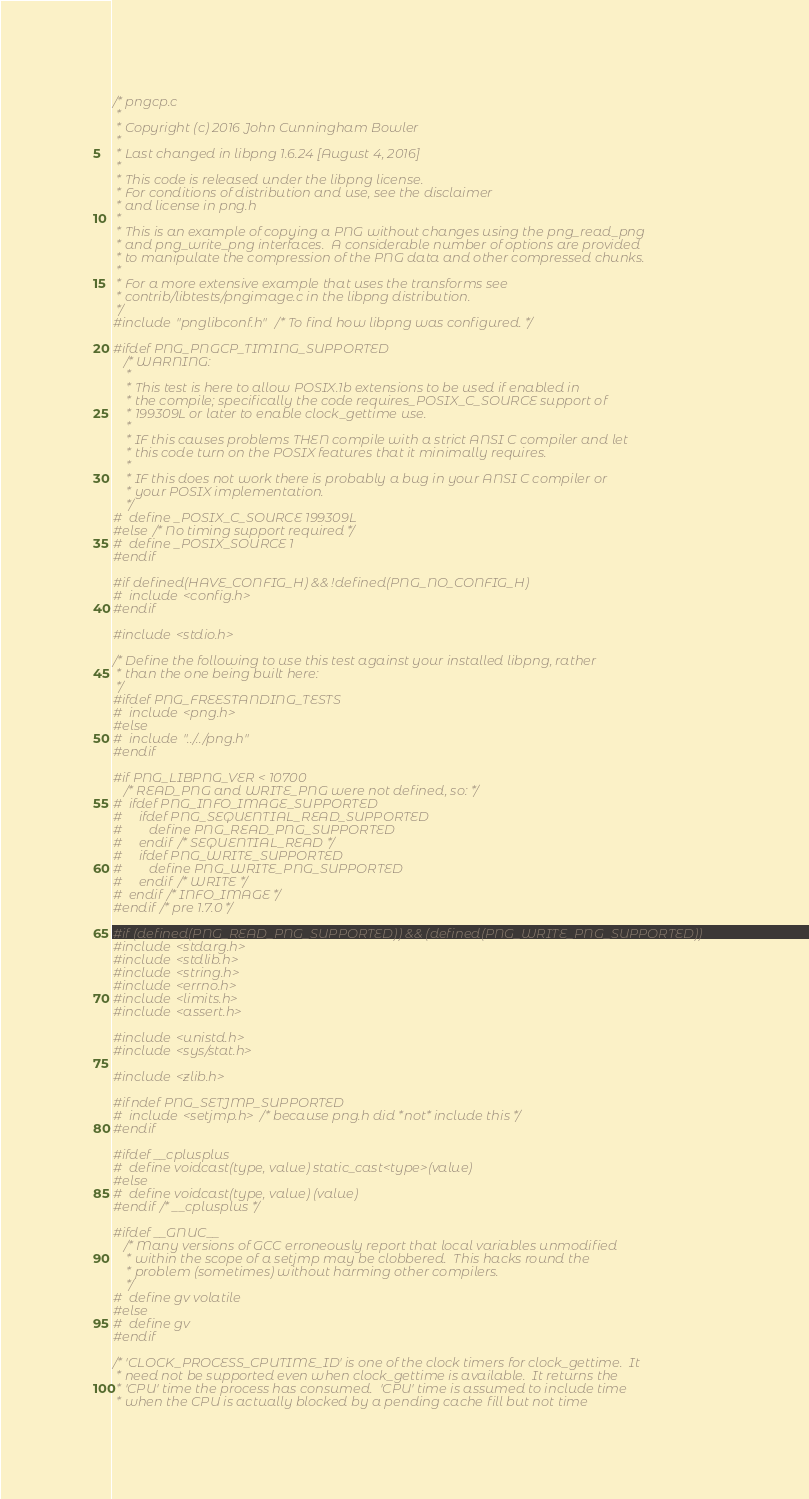<code> <loc_0><loc_0><loc_500><loc_500><_C_>/* pngcp.c
 *
 * Copyright (c) 2016 John Cunningham Bowler
 *
 * Last changed in libpng 1.6.24 [August 4, 2016]
 *
 * This code is released under the libpng license.
 * For conditions of distribution and use, see the disclaimer
 * and license in png.h
 *
 * This is an example of copying a PNG without changes using the png_read_png
 * and png_write_png interfaces.  A considerable number of options are provided
 * to manipulate the compression of the PNG data and other compressed chunks.
 *
 * For a more extensive example that uses the transforms see
 * contrib/libtests/pngimage.c in the libpng distribution.
 */
#include "pnglibconf.h" /* To find how libpng was configured. */

#ifdef PNG_PNGCP_TIMING_SUPPORTED
   /* WARNING:
    *
    * This test is here to allow POSIX.1b extensions to be used if enabled in
    * the compile; specifically the code requires_POSIX_C_SOURCE support of
    * 199309L or later to enable clock_gettime use.
    *
    * IF this causes problems THEN compile with a strict ANSI C compiler and let
    * this code turn on the POSIX features that it minimally requires.
    *
    * IF this does not work there is probably a bug in your ANSI C compiler or
    * your POSIX implementation.
    */
#  define _POSIX_C_SOURCE 199309L
#else /* No timing support required */
#  define _POSIX_SOURCE 1
#endif

#if defined(HAVE_CONFIG_H) && !defined(PNG_NO_CONFIG_H)
#  include <config.h>
#endif

#include <stdio.h>

/* Define the following to use this test against your installed libpng, rather
 * than the one being built here:
 */
#ifdef PNG_FREESTANDING_TESTS
#  include <png.h>
#else
#  include "../../png.h"
#endif

#if PNG_LIBPNG_VER < 10700
   /* READ_PNG and WRITE_PNG were not defined, so: */
#  ifdef PNG_INFO_IMAGE_SUPPORTED
#     ifdef PNG_SEQUENTIAL_READ_SUPPORTED
#        define PNG_READ_PNG_SUPPORTED
#     endif /* SEQUENTIAL_READ */
#     ifdef PNG_WRITE_SUPPORTED
#        define PNG_WRITE_PNG_SUPPORTED
#     endif /* WRITE */
#  endif /* INFO_IMAGE */
#endif /* pre 1.7.0 */

#if (defined(PNG_READ_PNG_SUPPORTED)) && (defined(PNG_WRITE_PNG_SUPPORTED))
#include <stdarg.h>
#include <stdlib.h>
#include <string.h>
#include <errno.h>
#include <limits.h>
#include <assert.h>

#include <unistd.h>
#include <sys/stat.h>

#include <zlib.h>

#ifndef PNG_SETJMP_SUPPORTED
#  include <setjmp.h> /* because png.h did *not* include this */
#endif

#ifdef __cplusplus
#  define voidcast(type, value) static_cast<type>(value)
#else
#  define voidcast(type, value) (value)
#endif /* __cplusplus */

#ifdef __GNUC__
   /* Many versions of GCC erroneously report that local variables unmodified
    * within the scope of a setjmp may be clobbered.  This hacks round the
    * problem (sometimes) without harming other compilers.
    */
#  define gv volatile
#else
#  define gv
#endif

/* 'CLOCK_PROCESS_CPUTIME_ID' is one of the clock timers for clock_gettime.  It
 * need not be supported even when clock_gettime is available.  It returns the
 * 'CPU' time the process has consumed.  'CPU' time is assumed to include time
 * when the CPU is actually blocked by a pending cache fill but not time</code> 